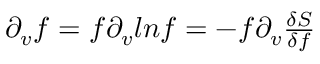Convert formula to latex. <formula><loc_0><loc_0><loc_500><loc_500>\begin{array} { r } { \partial _ { v } f = f \partial _ { v } \ln f = - f \partial _ { v } \frac { \delta S } { \delta f } } \end{array}</formula> 